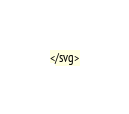<code> <loc_0><loc_0><loc_500><loc_500><_PHP_></svg>
</code> 